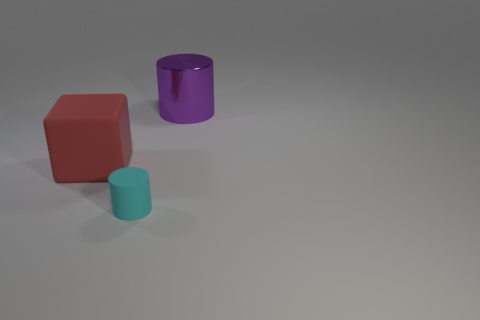Is there any other thing that has the same shape as the big matte thing?
Offer a very short reply. No. How many other big things are the same color as the large shiny object?
Provide a short and direct response. 0. There is a red object that is the same size as the shiny cylinder; what shape is it?
Give a very brief answer. Cube. Are there any other objects of the same size as the purple shiny object?
Ensure brevity in your answer.  Yes. There is a red block that is the same size as the purple metal thing; what material is it?
Keep it short and to the point. Rubber. How big is the object that is in front of the big object that is to the left of the cyan cylinder?
Offer a terse response. Small. Does the cylinder that is behind the red rubber cube have the same size as the big red matte thing?
Make the answer very short. Yes. Are there more large things that are in front of the shiny object than tiny rubber things on the right side of the tiny cyan object?
Your answer should be compact. Yes. The thing that is both on the right side of the large red thing and to the left of the purple thing has what shape?
Make the answer very short. Cylinder. There is a large purple metallic thing that is behind the cyan thing; what is its shape?
Provide a succinct answer. Cylinder. 